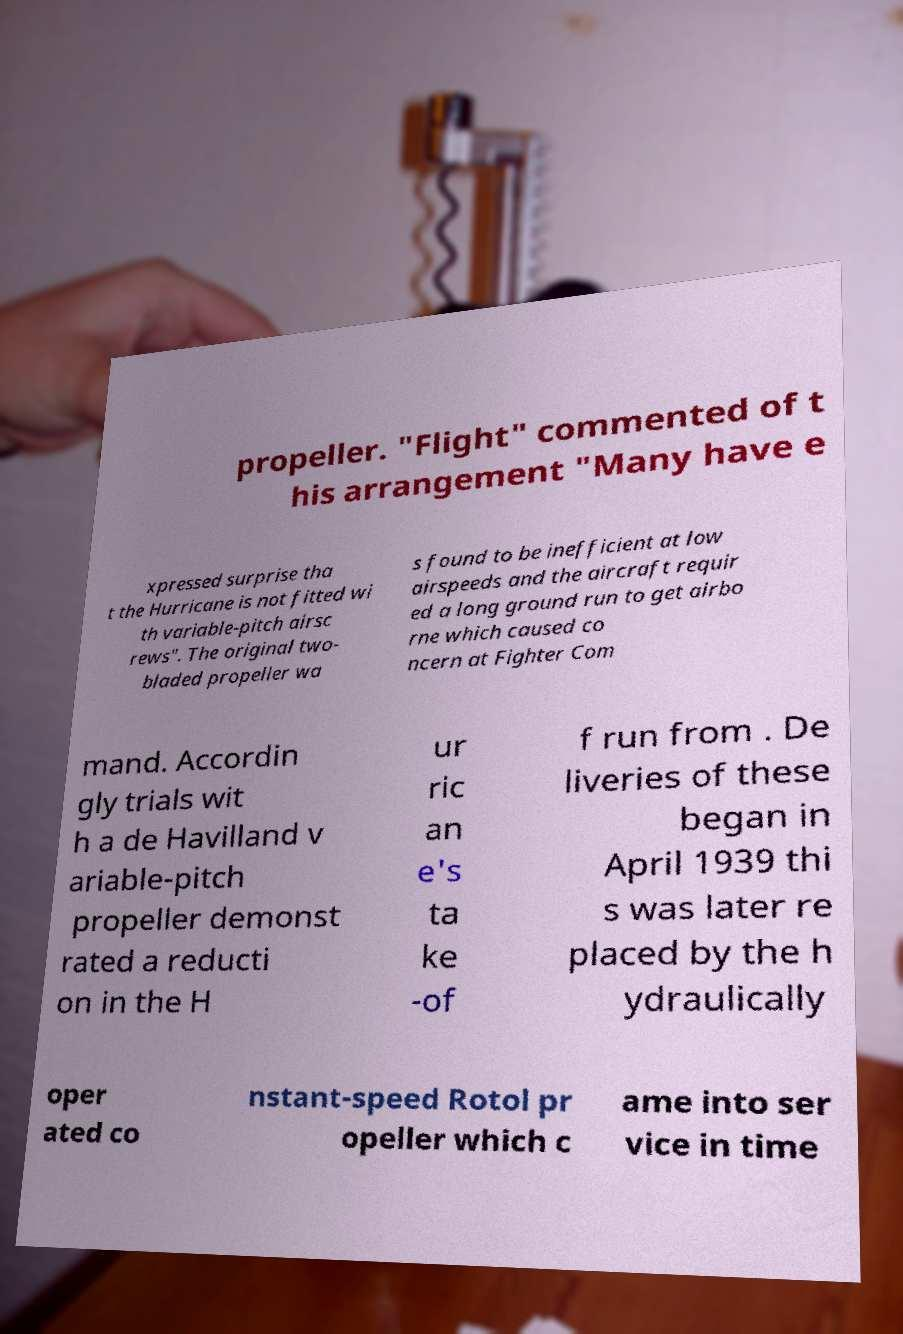Please identify and transcribe the text found in this image. propeller. "Flight" commented of t his arrangement "Many have e xpressed surprise tha t the Hurricane is not fitted wi th variable-pitch airsc rews". The original two- bladed propeller wa s found to be inefficient at low airspeeds and the aircraft requir ed a long ground run to get airbo rne which caused co ncern at Fighter Com mand. Accordin gly trials wit h a de Havilland v ariable-pitch propeller demonst rated a reducti on in the H ur ric an e's ta ke -of f run from . De liveries of these began in April 1939 thi s was later re placed by the h ydraulically oper ated co nstant-speed Rotol pr opeller which c ame into ser vice in time 